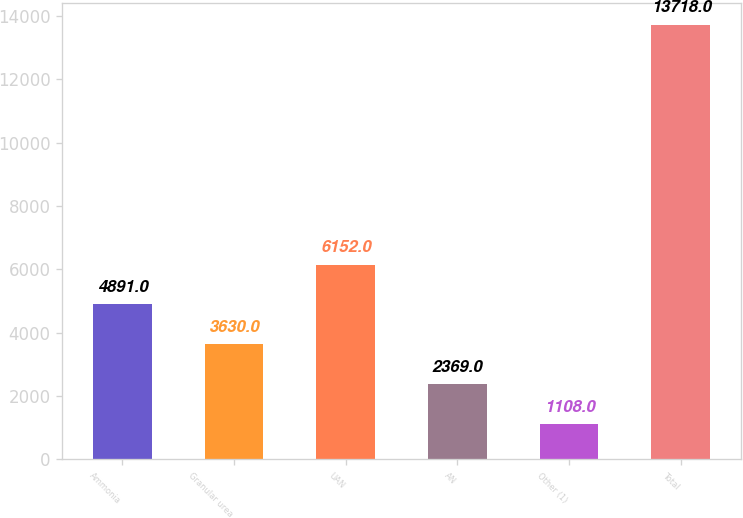<chart> <loc_0><loc_0><loc_500><loc_500><bar_chart><fcel>Ammonia<fcel>Granular urea<fcel>UAN<fcel>AN<fcel>Other (1)<fcel>Total<nl><fcel>4891<fcel>3630<fcel>6152<fcel>2369<fcel>1108<fcel>13718<nl></chart> 